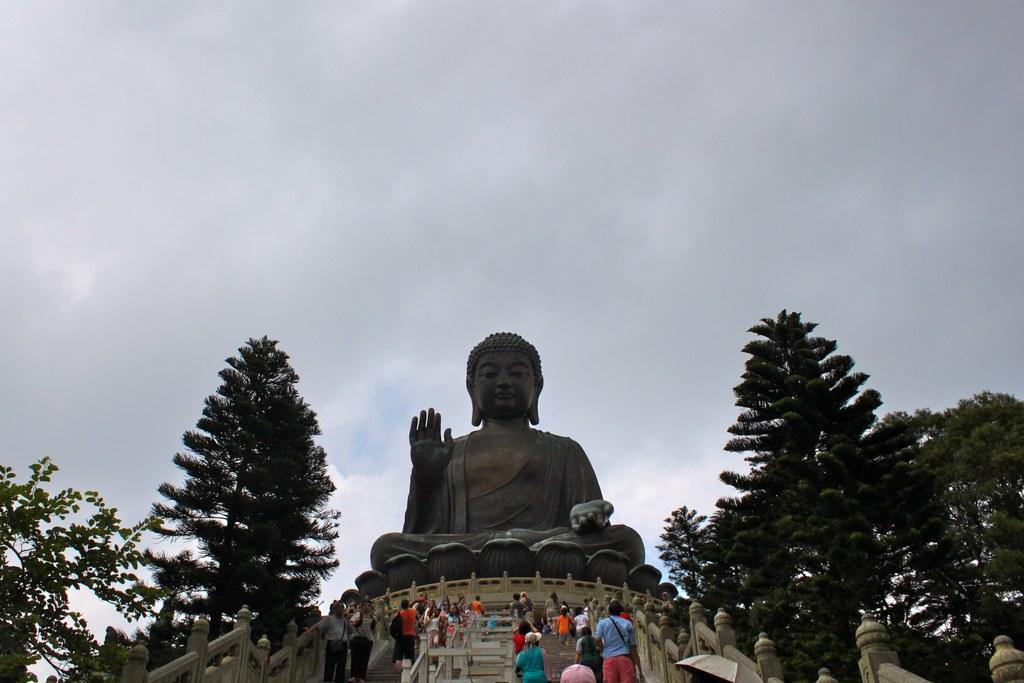Describe this image in one or two sentences. This picture contains the statue of the Buddha. At the bottom of the picture, we see a staircase. On either side of the picture, we see trees. At the top of the picture, we see the sky. 